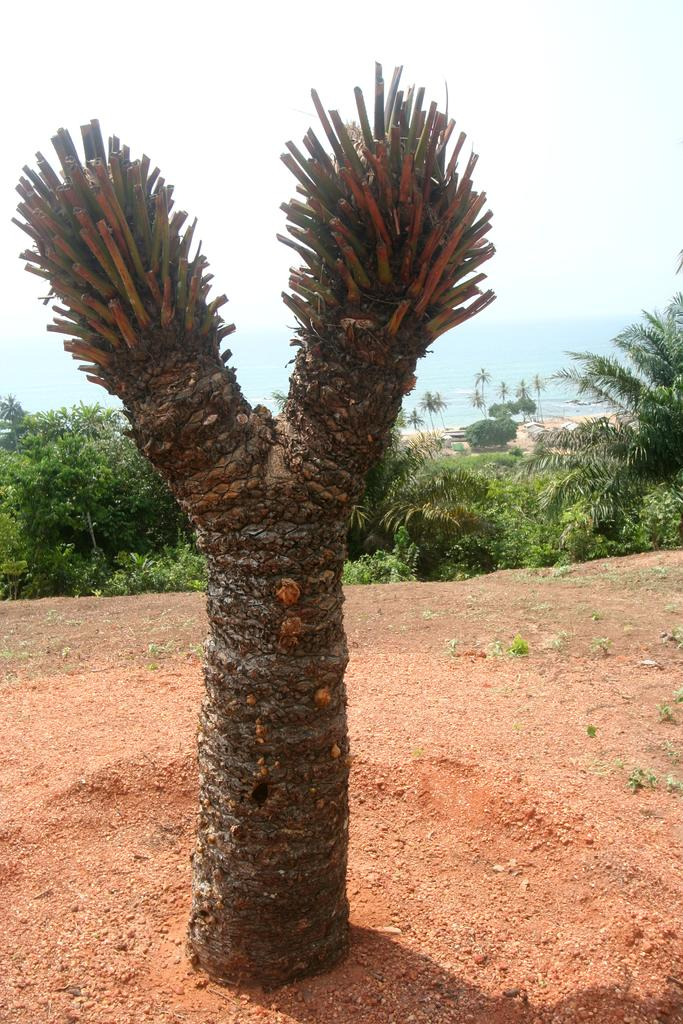What is located on the ground in the image? There is a tree on the ground in the image. What can be seen in the background of the image? Trees and water are visible in the background of the image. What else is visible in the background of the image? The sky is visible in the background of the image. Reasoning: Let' Let's think step by step in order to produce the conversation. We start by identifying the main subject on the ground, which is the tree. Then, we expand the conversation to include the background elements, such as trees, water, and the sky. Each question is designed to elicit a specific detail about the image that is known from the provided facts. Absurd Question/Answer: How many deer can be seen in the image? There are no deer present in the image. What type of mine is visible in the image? There is no mine present in the image. What type of liquid is being poured from the sky in the image? There is no liquid being poured from the sky in the image; it is the sky itself that is visible in the background. 